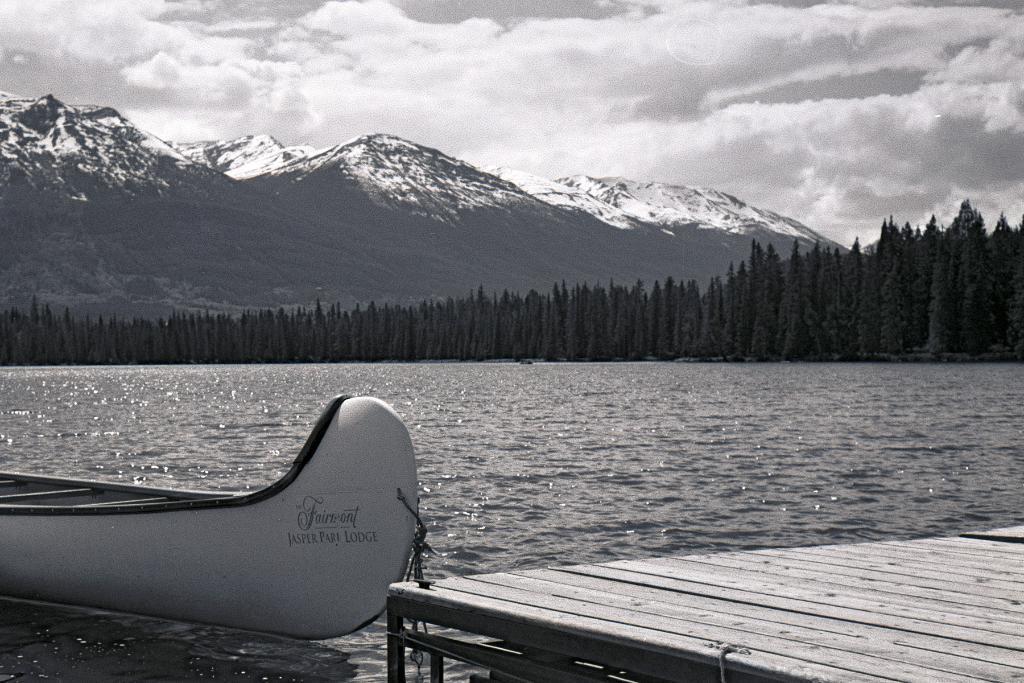Please provide a concise description of this image. This is black and white image where we can see a boat on the surface of water and a wooden platform. Background of the image trees and mountains are there. At the top of the image, the sky is covered with clouds. 